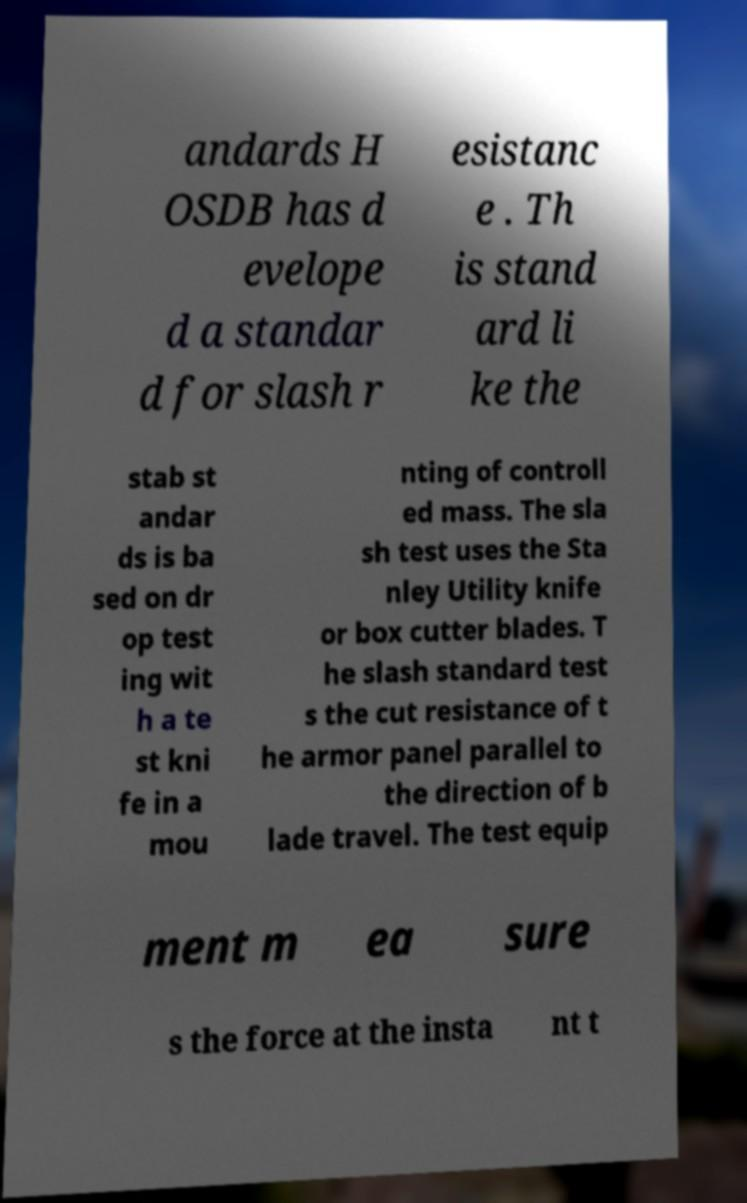What messages or text are displayed in this image? I need them in a readable, typed format. andards H OSDB has d evelope d a standar d for slash r esistanc e . Th is stand ard li ke the stab st andar ds is ba sed on dr op test ing wit h a te st kni fe in a mou nting of controll ed mass. The sla sh test uses the Sta nley Utility knife or box cutter blades. T he slash standard test s the cut resistance of t he armor panel parallel to the direction of b lade travel. The test equip ment m ea sure s the force at the insta nt t 